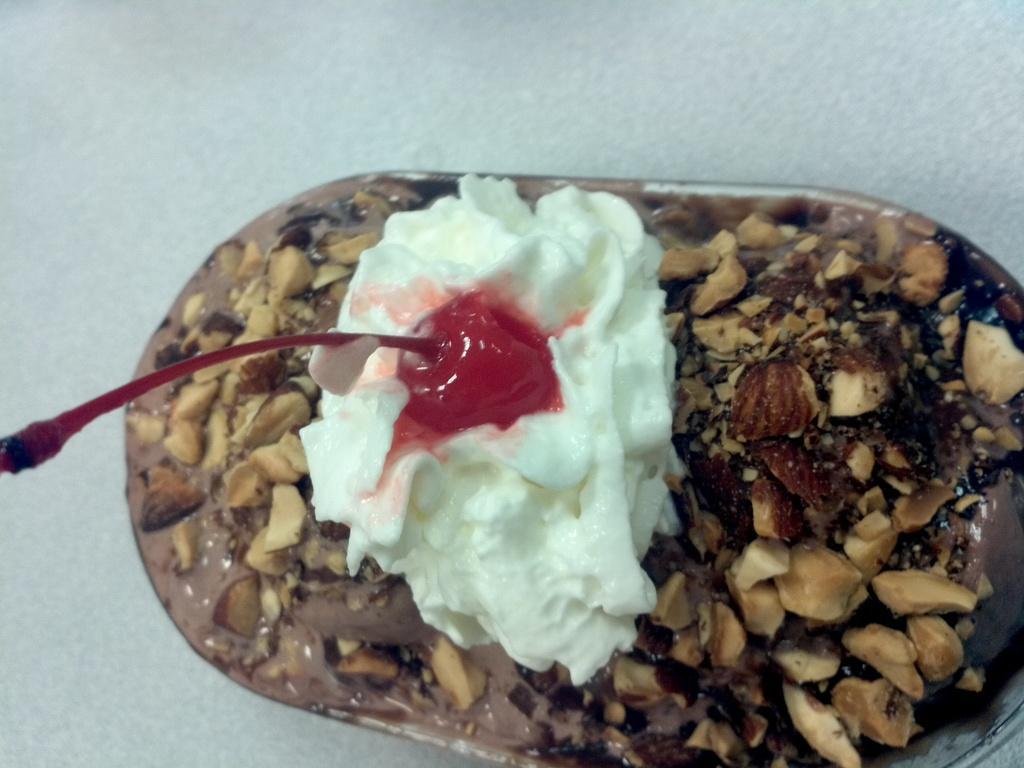Could you give a brief overview of what you see in this image? In this image there is a food item on the white color surface. 